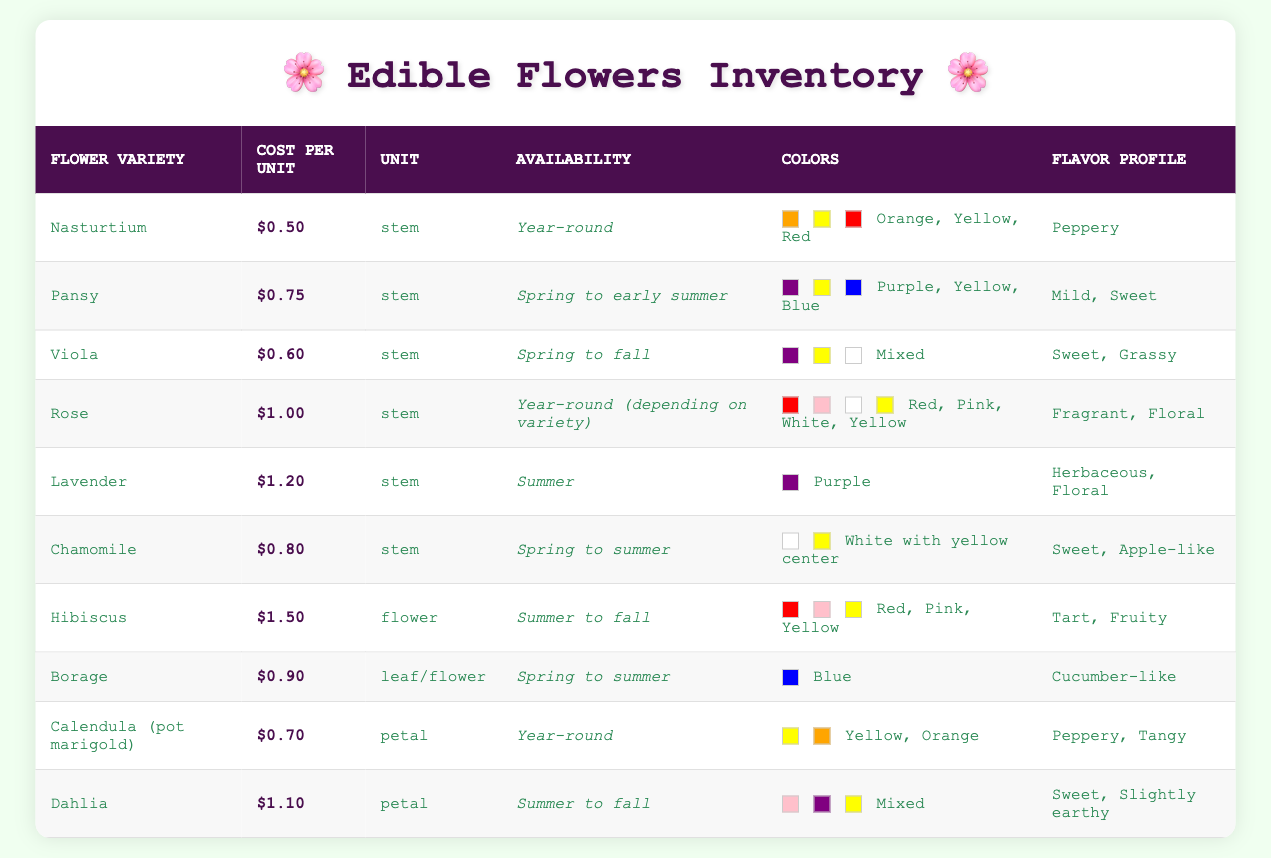What is the cost per unit of Nasturtium? The table shows that Nasturtium has a cost per unit of $0.50 as directly listed in the corresponding cell.
Answer: $0.50 Which flower has the highest cost per unit? By inspecting the cost per unit column, Hibiscus costs $1.50 per flower, which is higher than all other flowers listed.
Answer: Hibiscus Is Rose available year-round? The availability column states that Rose is available year-round but may depend on the variety, confirming that it can be available throughout the year.
Answer: Yes What is the total cost of purchasing one stem each of Nasturtium, Pansy, and Viola? The individual costs are $0.50, $0.75, and $0.60 respectively. Summing these gives $0.50 + $0.75 + $0.60 = $1.85, which is the total cost for the three stems.
Answer: $1.85 What flavor profile do Chamomile flowers have? The table indicates that Chamomile has a flavor profile described as sweet and apple-like.
Answer: Sweet, apple-like Are there any flowers in the inventory that are available year-round? By reviewing the availability column, Nasturtium and Calendula (pot marigold) both indicate year-round availability, confirming the presence of such flowers.
Answer: Yes What is the average cost per unit of flowers available in summer? To find this, we calculate the costs for flowers available in summer: Lavender ($1.20), Hibiscus ($1.50), and Borage ($0.90). Their total is $1.20 + $1.50 + $0.90 = $3.60. There are three flowers, so the average is $3.60 / 3 = $1.20.
Answer: $1.20 How many flowers have a flavor profile that is sweet? Checking the flavor profile, both Pansy and Viola are noted as sweet, and Chamomile is also described as sweet and apple-like. Counting these gives a total of three flowers with sweet flavor profiles.
Answer: Three Which flower has a flavor profile that is tart? Looking at the flavor profile column, Hibiscus is the only flower listed with a flavor profile of tart and fruity.
Answer: Hibiscus 